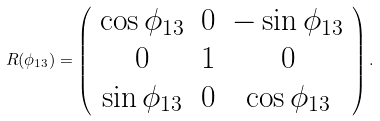Convert formula to latex. <formula><loc_0><loc_0><loc_500><loc_500>R ( \phi _ { 1 3 } ) = \left ( \begin{array} { c c c } \cos \phi _ { 1 3 } & 0 & - \sin \phi _ { 1 3 } \\ 0 & 1 & 0 \\ \sin \phi _ { 1 3 } & 0 & \cos \phi _ { 1 3 } \\ \end{array} \right ) .</formula> 